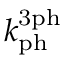Convert formula to latex. <formula><loc_0><loc_0><loc_500><loc_500>k _ { p h } ^ { 3 p h }</formula> 